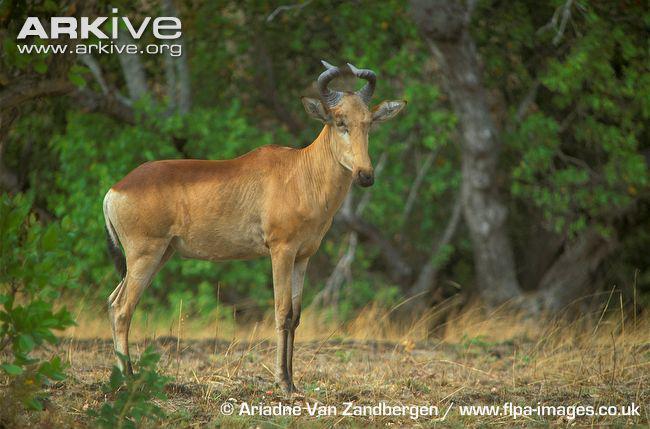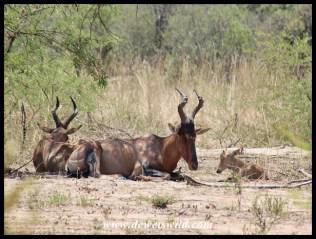The first image is the image on the left, the second image is the image on the right. Given the left and right images, does the statement "There are exactly two animals standing." hold true? Answer yes or no. No. The first image is the image on the left, the second image is the image on the right. Evaluate the accuracy of this statement regarding the images: "There is a total of two elk.". Is it true? Answer yes or no. No. 